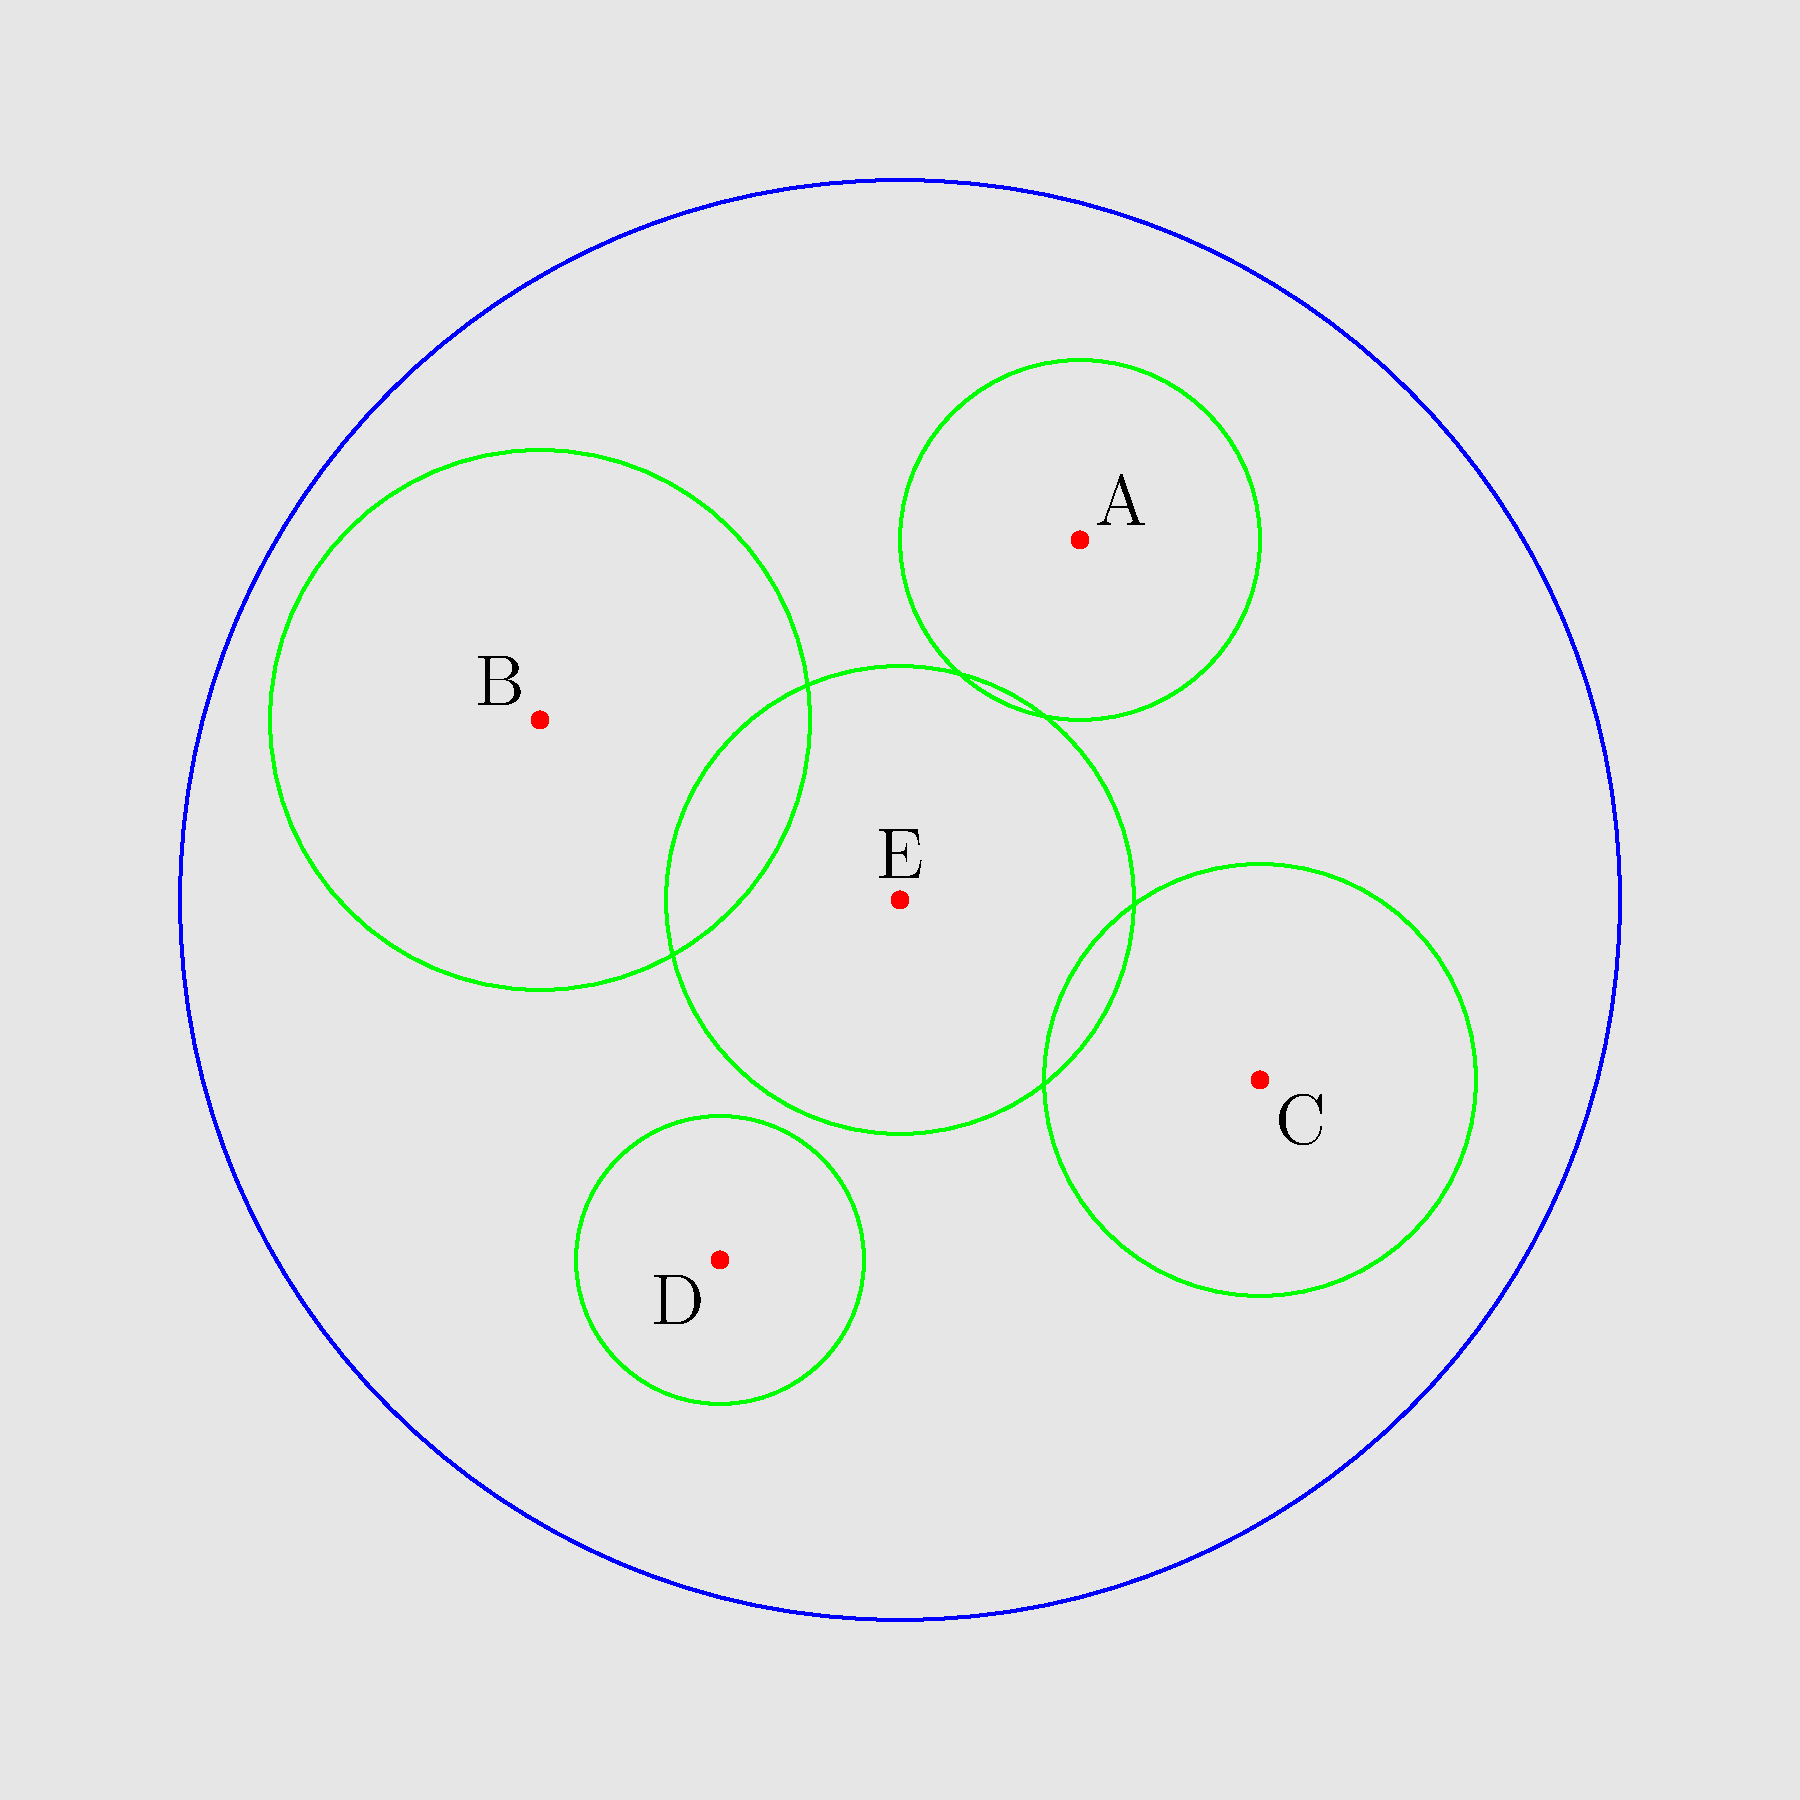Based on the map showing library branches (A-E) and their service areas, which branch has the largest service area radius and is likely serving the most extensive geographical region? To determine which branch has the largest service area radius, we need to compare the sizes of the green circles representing each branch's service area:

1. Branch A: Located at (1,2), has a service area with radius ≈ 1 unit
2. Branch B: Located at (-2,1), has a service area with radius ≈ 1.5 units
3. Branch C: Located at (2,-1), has a service area with radius ≈ 1.2 units
4. Branch D: Located at (-1,-2), has a service area with radius ≈ 0.8 units
5. Branch E: Located at (0,0), has a service area with radius ≈ 1.3 units

Comparing these radii, we can see that Branch B has the largest service area radius at approximately 1.5 units. This indicates that Branch B is likely serving the most extensive geographical region among all the branches shown on the map.
Answer: Branch B 